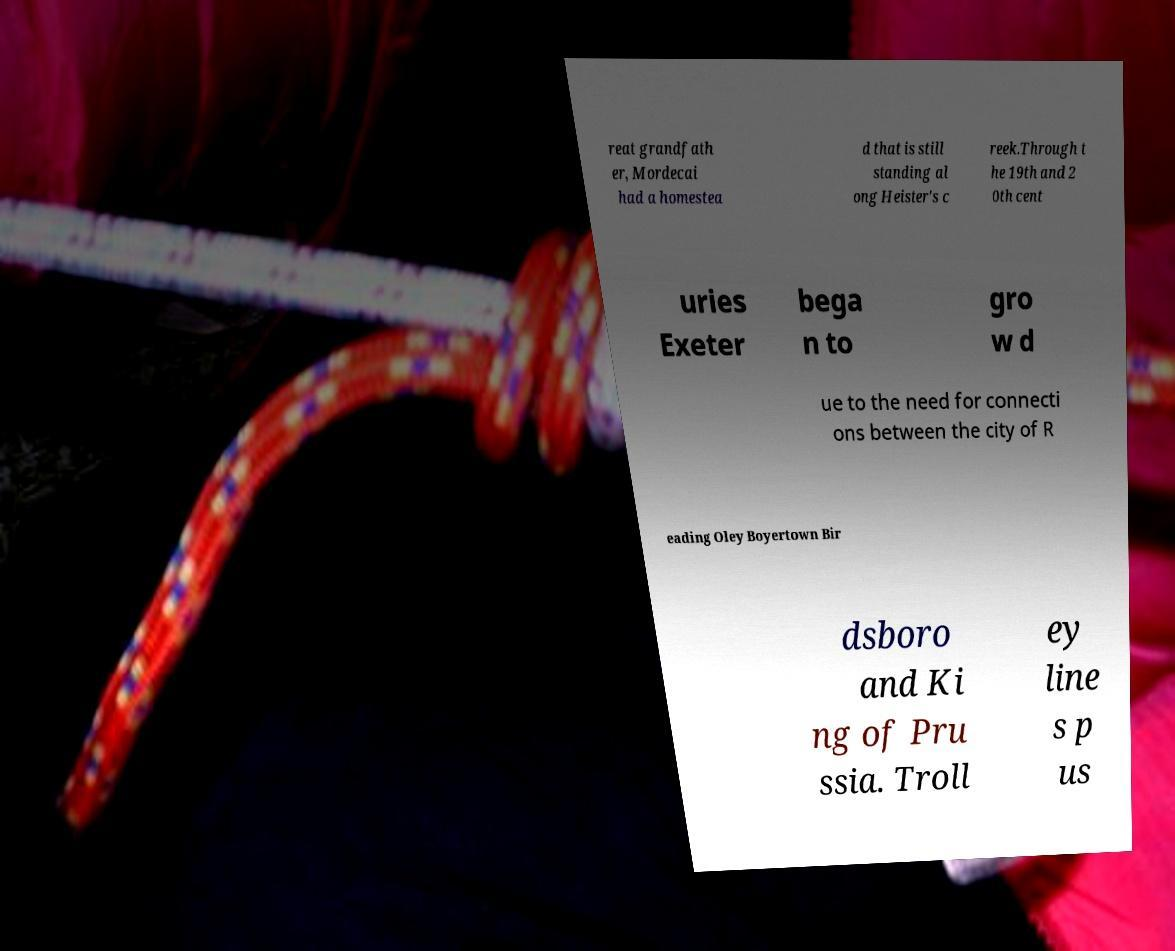Please read and relay the text visible in this image. What does it say? reat grandfath er, Mordecai had a homestea d that is still standing al ong Heister's c reek.Through t he 19th and 2 0th cent uries Exeter bega n to gro w d ue to the need for connecti ons between the city of R eading Oley Boyertown Bir dsboro and Ki ng of Pru ssia. Troll ey line s p us 